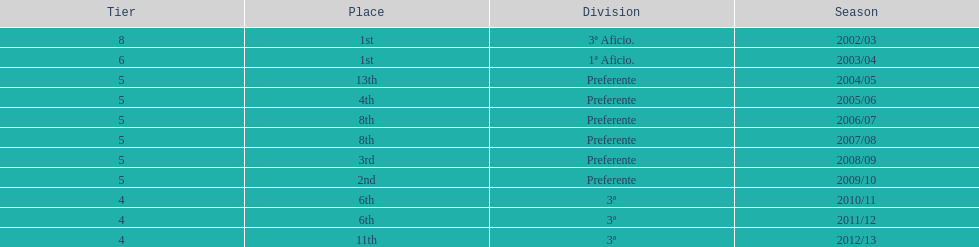How many seasons did internacional de madrid cf play in the preferente division? 6. 